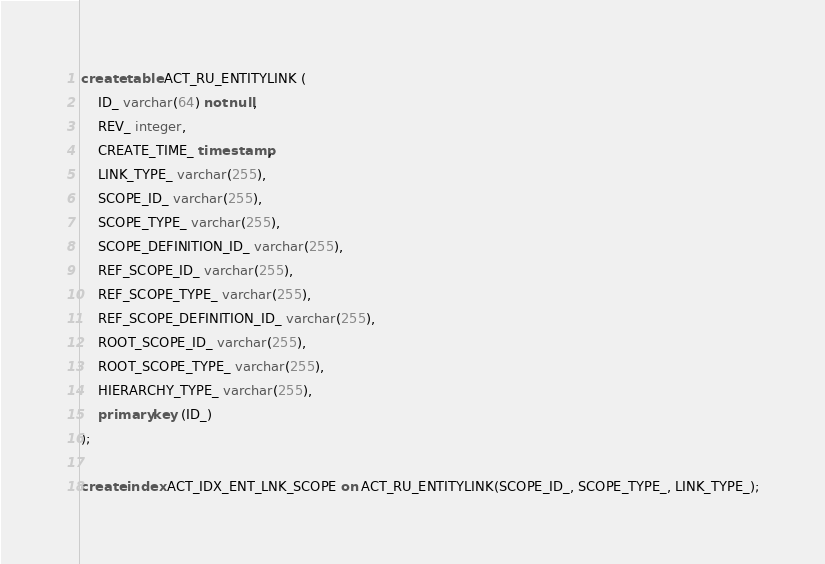Convert code to text. <code><loc_0><loc_0><loc_500><loc_500><_SQL_>create table ACT_RU_ENTITYLINK (
    ID_ varchar(64) not null,
    REV_ integer,
    CREATE_TIME_ timestamp,
    LINK_TYPE_ varchar(255),
    SCOPE_ID_ varchar(255),
    SCOPE_TYPE_ varchar(255),
    SCOPE_DEFINITION_ID_ varchar(255),
    REF_SCOPE_ID_ varchar(255),
    REF_SCOPE_TYPE_ varchar(255),
    REF_SCOPE_DEFINITION_ID_ varchar(255),
    ROOT_SCOPE_ID_ varchar(255),
    ROOT_SCOPE_TYPE_ varchar(255),
    HIERARCHY_TYPE_ varchar(255),
    primary key (ID_)
);

create index ACT_IDX_ENT_LNK_SCOPE on ACT_RU_ENTITYLINK(SCOPE_ID_, SCOPE_TYPE_, LINK_TYPE_);</code> 